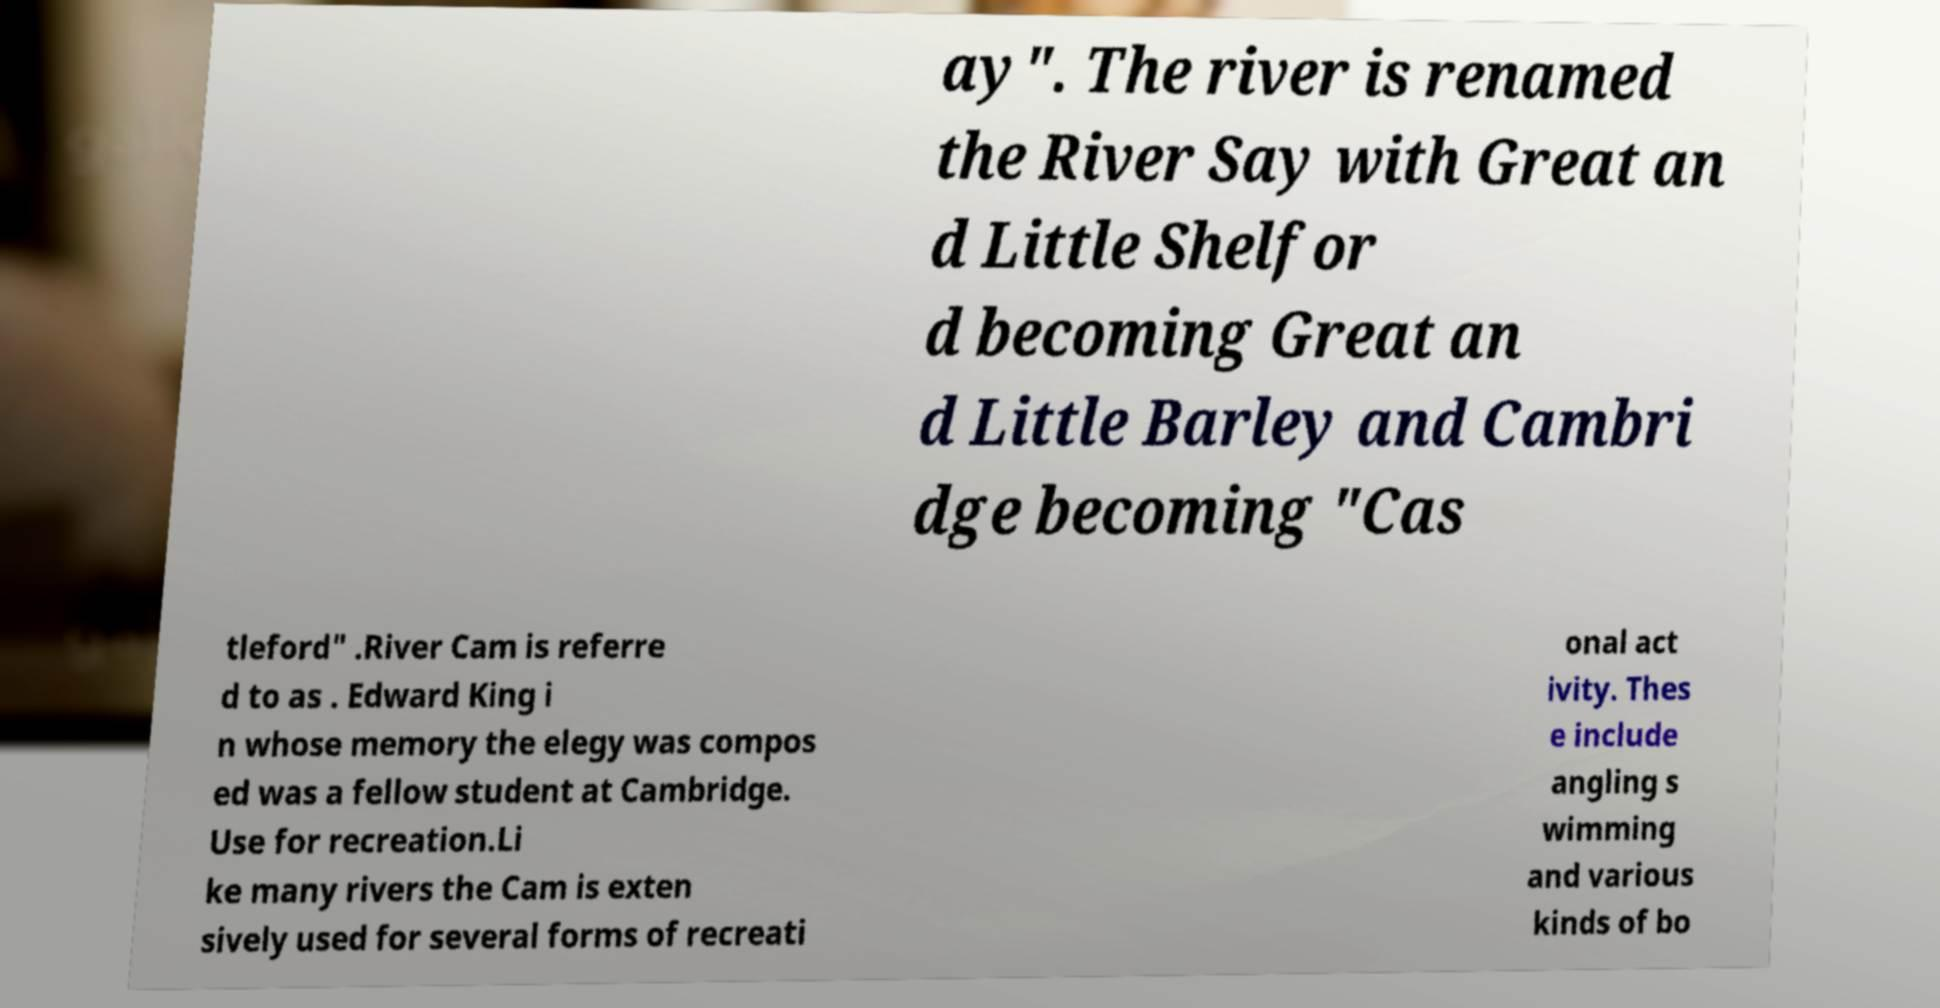Please read and relay the text visible in this image. What does it say? ay". The river is renamed the River Say with Great an d Little Shelfor d becoming Great an d Little Barley and Cambri dge becoming "Cas tleford" .River Cam is referre d to as . Edward King i n whose memory the elegy was compos ed was a fellow student at Cambridge. Use for recreation.Li ke many rivers the Cam is exten sively used for several forms of recreati onal act ivity. Thes e include angling s wimming and various kinds of bo 